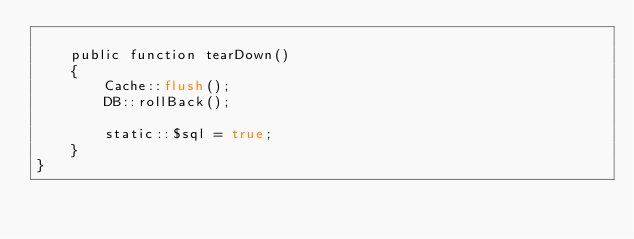Convert code to text. <code><loc_0><loc_0><loc_500><loc_500><_PHP_>
    public function tearDown()
    {
        Cache::flush();
        DB::rollBack();

        static::$sql = true;
    }
}
</code> 